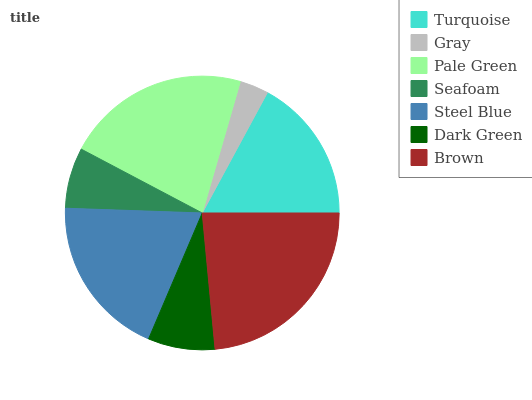Is Gray the minimum?
Answer yes or no. Yes. Is Brown the maximum?
Answer yes or no. Yes. Is Pale Green the minimum?
Answer yes or no. No. Is Pale Green the maximum?
Answer yes or no. No. Is Pale Green greater than Gray?
Answer yes or no. Yes. Is Gray less than Pale Green?
Answer yes or no. Yes. Is Gray greater than Pale Green?
Answer yes or no. No. Is Pale Green less than Gray?
Answer yes or no. No. Is Turquoise the high median?
Answer yes or no. Yes. Is Turquoise the low median?
Answer yes or no. Yes. Is Brown the high median?
Answer yes or no. No. Is Dark Green the low median?
Answer yes or no. No. 